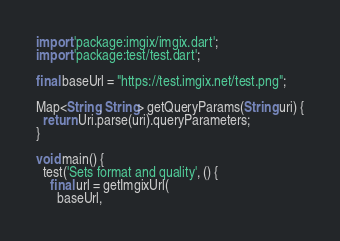Convert code to text. <code><loc_0><loc_0><loc_500><loc_500><_Dart_>import 'package:imgix/imgix.dart';
import 'package:test/test.dart';

final baseUrl = "https://test.imgix.net/test.png";

Map<String, String> getQueryParams(String uri) {
  return Uri.parse(uri).queryParameters;
}

void main() {
  test('Sets format and quality', () {
    final url = getImgixUrl(
      baseUrl,</code> 